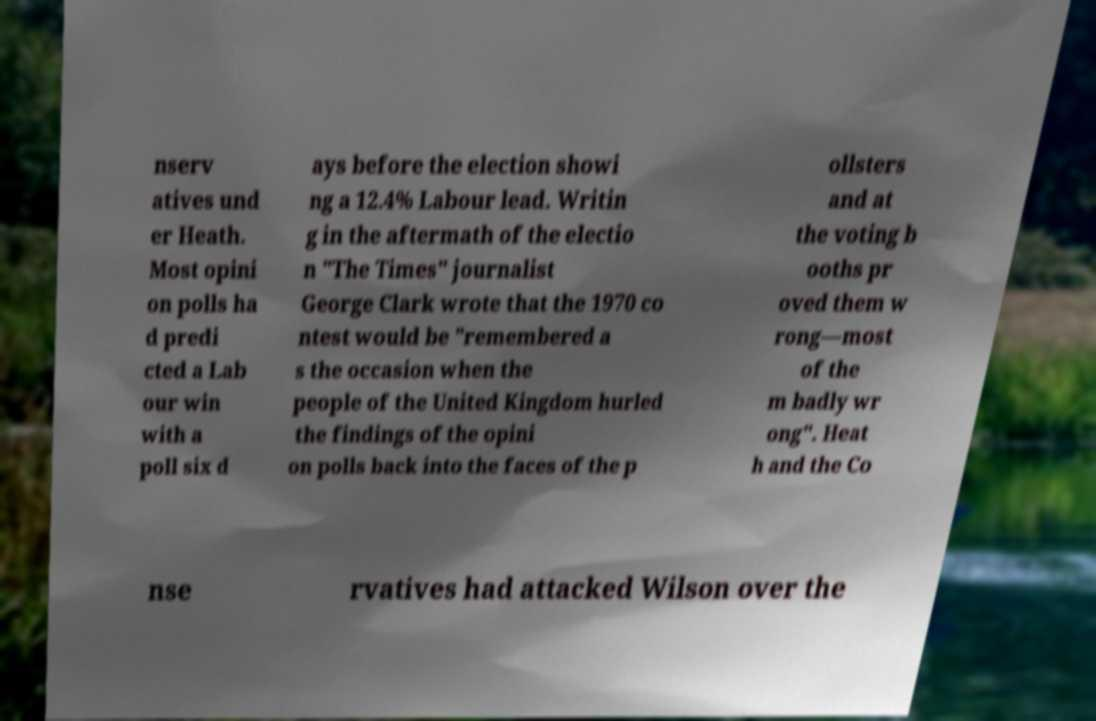Could you extract and type out the text from this image? nserv atives und er Heath. Most opini on polls ha d predi cted a Lab our win with a poll six d ays before the election showi ng a 12.4% Labour lead. Writin g in the aftermath of the electio n "The Times" journalist George Clark wrote that the 1970 co ntest would be "remembered a s the occasion when the people of the United Kingdom hurled the findings of the opini on polls back into the faces of the p ollsters and at the voting b ooths pr oved them w rong—most of the m badly wr ong". Heat h and the Co nse rvatives had attacked Wilson over the 